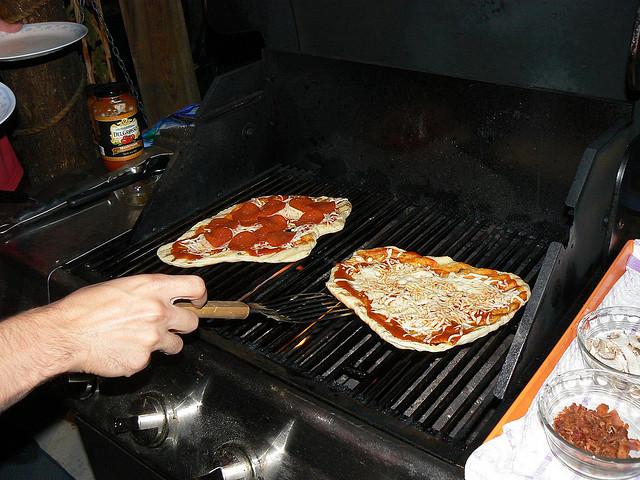How are these pizzas being cooked?
Quick response, please. Grill. What toppings are on the pizza on the left?
Answer briefly. Pepperoni. What cuisine is being grilled?
Short answer required. Pizza. Is the pizza done?
Concise answer only. No. Do you see a brick wall?
Give a very brief answer. No. What toppings are on the pizzas?
Short answer required. Pepperoni and cheese. Is the food homemade?
Concise answer only. Yes. Are there mushrooms?
Answer briefly. No. 